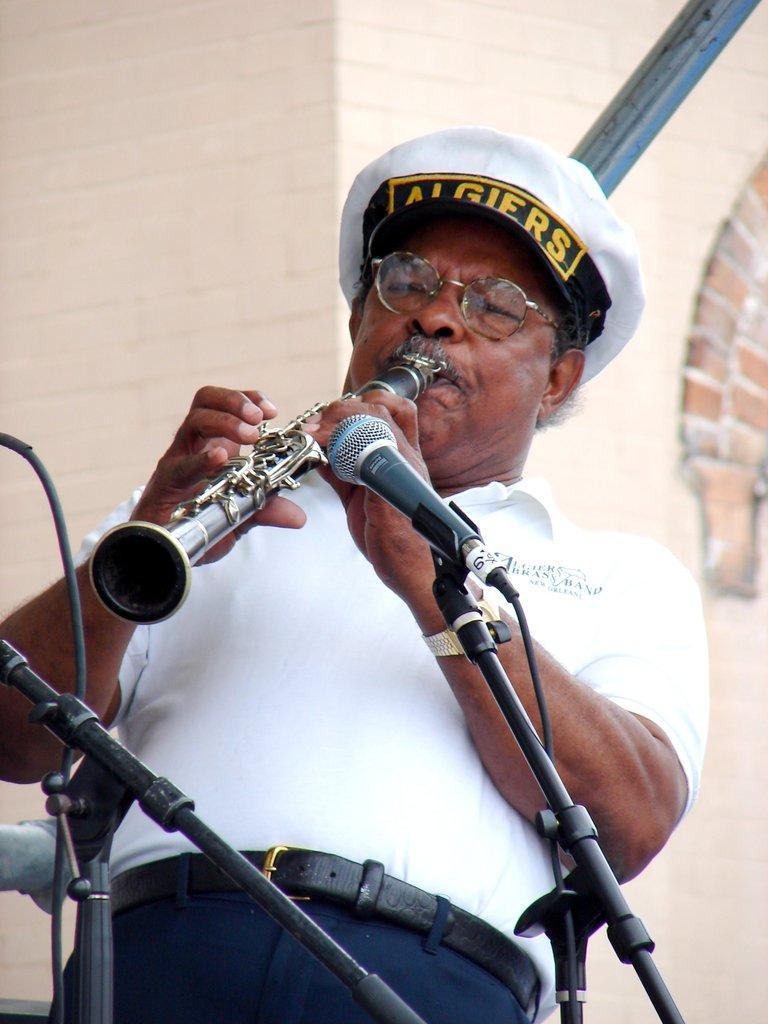Describe this image in one or two sentences. In the image there is a man with white t-shirt, pant with belt, cap on his head and he kept spectacles. He is holding the musical instrument and playing. In front of him there are two mics with mic stands and wires. In the background there is a wall with bricks. And also there is a black pole. 